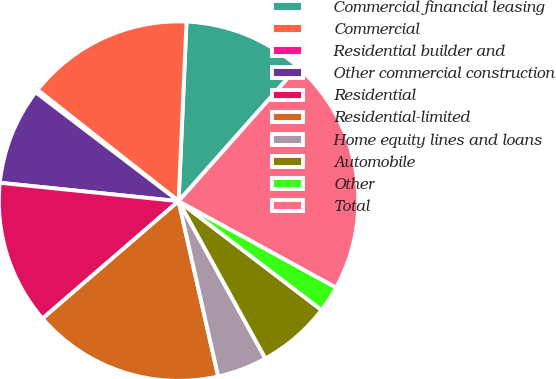Convert chart. <chart><loc_0><loc_0><loc_500><loc_500><pie_chart><fcel>Commercial financial leasing<fcel>Commercial<fcel>Residential builder and<fcel>Other commercial construction<fcel>Residential<fcel>Residential-limited<fcel>Home equity lines and loans<fcel>Automobile<fcel>Other<fcel>Total<nl><fcel>10.85%<fcel>15.08%<fcel>0.26%<fcel>8.73%<fcel>12.96%<fcel>17.2%<fcel>4.49%<fcel>6.61%<fcel>2.38%<fcel>21.43%<nl></chart> 